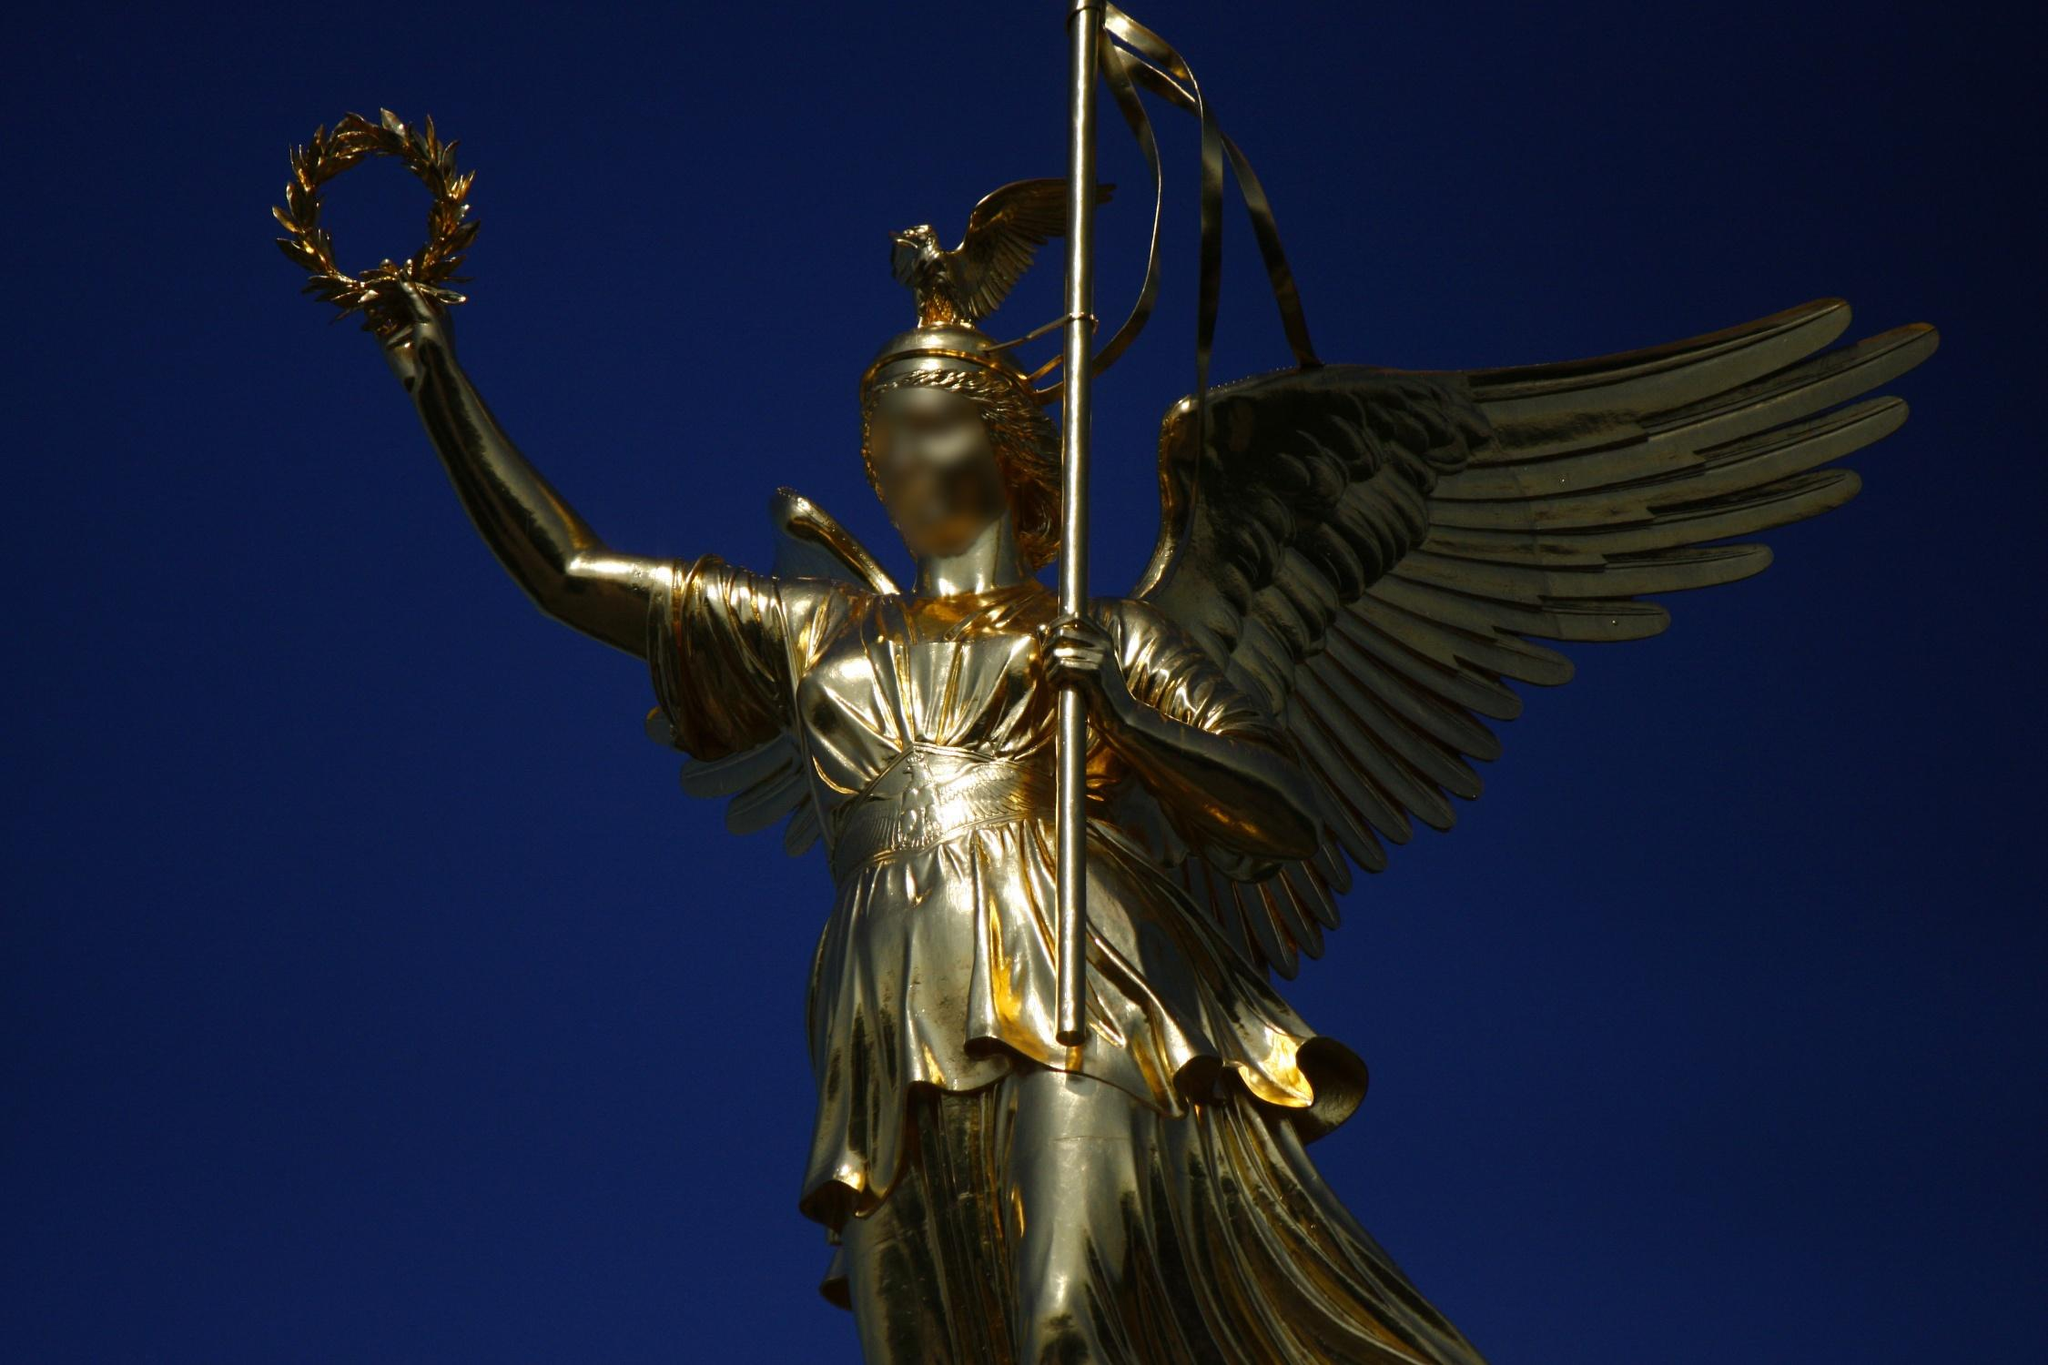Describe the artistic details and materials used in the creation of the statue atop the Victory Column. The statue of Victoria atop the Victory Column is a masterpiece of bronze sculpture, meticulously covered in gold leaf. Her regal pose is characterized by dynamic movement, with wings outstretched as if in flight. The gold leaf gives the statue an opulent glow, symbolizing glory and triumph. Each detail, from the delicate folds of her robe to the fine feathers of her wings, is crafted with precision, showcasing the artisans' dedication to capturing both the physical and divine aspects of the goddess. How do the visual elements of the Victory Column contribute to its significance as a cultural landmark? The visual elements of the Victory Column, including its towering height, the gleaming golden statue, and the intricate details of Victoria's figure, all culminate to create a powerful symbol of triumph and resilience. The low-angle view often captured in photographs emphasizes the monument's grandeur, making it appear as if Victoria is soaring into the sky, reinforcing the themes of victory and aspiration. The combination of classical mythology and modern history in its design serves to bridge different eras, making it a poignant cultural landmark that embodies both historical achievements and ongoing aspirations. 